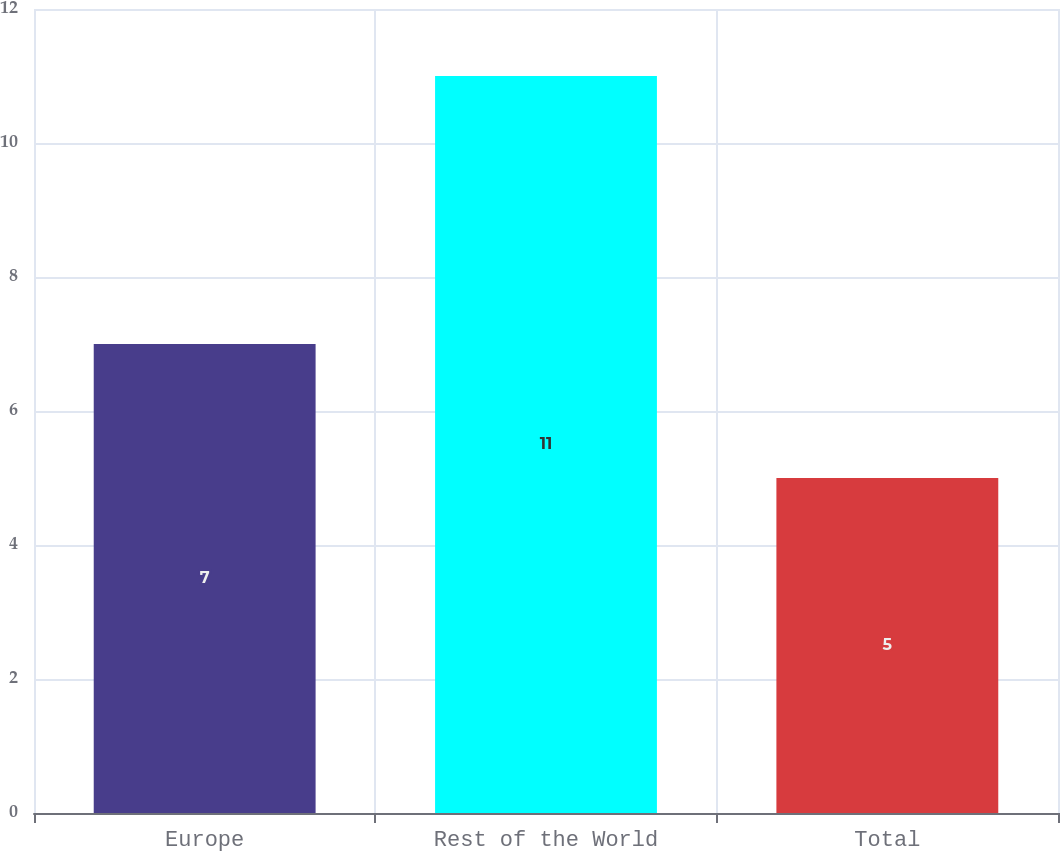<chart> <loc_0><loc_0><loc_500><loc_500><bar_chart><fcel>Europe<fcel>Rest of the World<fcel>Total<nl><fcel>7<fcel>11<fcel>5<nl></chart> 